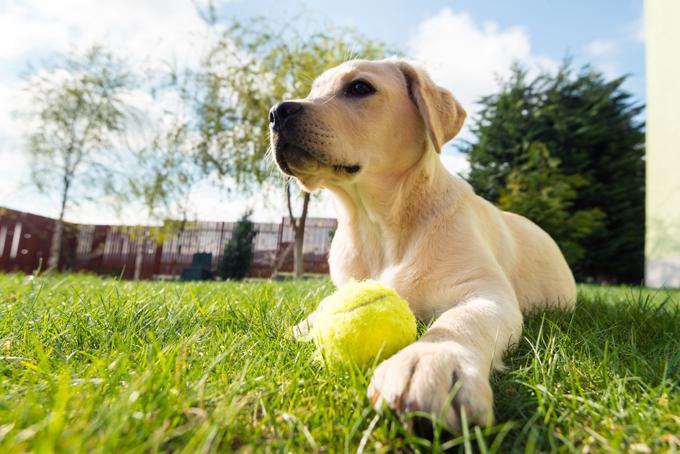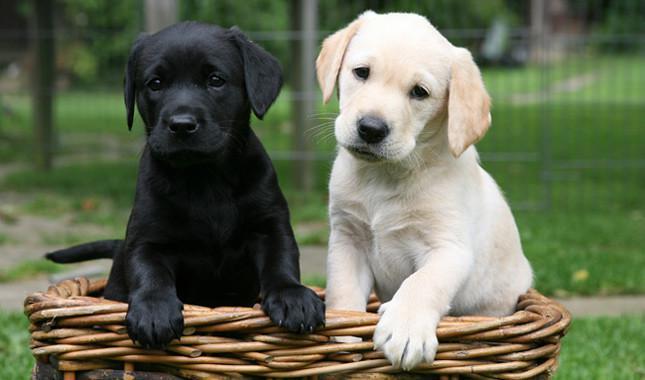The first image is the image on the left, the second image is the image on the right. Analyze the images presented: Is the assertion "The right image shows exactly two puppies side by side." valid? Answer yes or no. Yes. 